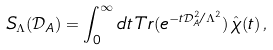<formula> <loc_0><loc_0><loc_500><loc_500>S _ { \Lambda } ( \mathcal { D } _ { A } ) = \int _ { 0 } ^ { \infty } d t \, T r ( e ^ { - t \mathcal { D } _ { A } ^ { 2 } / \Lambda ^ { 2 } } ) \, \hat { \chi } ( t ) \, ,</formula> 